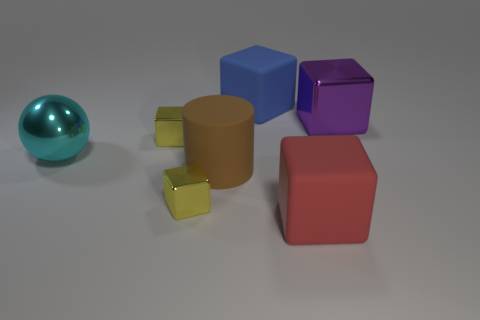Subtract 2 blocks. How many blocks are left? 3 Subtract all red blocks. How many blocks are left? 4 Subtract all blue cubes. How many cubes are left? 4 Subtract all green blocks. Subtract all yellow spheres. How many blocks are left? 5 Add 3 tiny purple shiny objects. How many objects exist? 10 Subtract 1 purple blocks. How many objects are left? 6 Subtract all blocks. How many objects are left? 2 Subtract all large rubber balls. Subtract all yellow things. How many objects are left? 5 Add 5 blue cubes. How many blue cubes are left? 6 Add 1 large cyan matte blocks. How many large cyan matte blocks exist? 1 